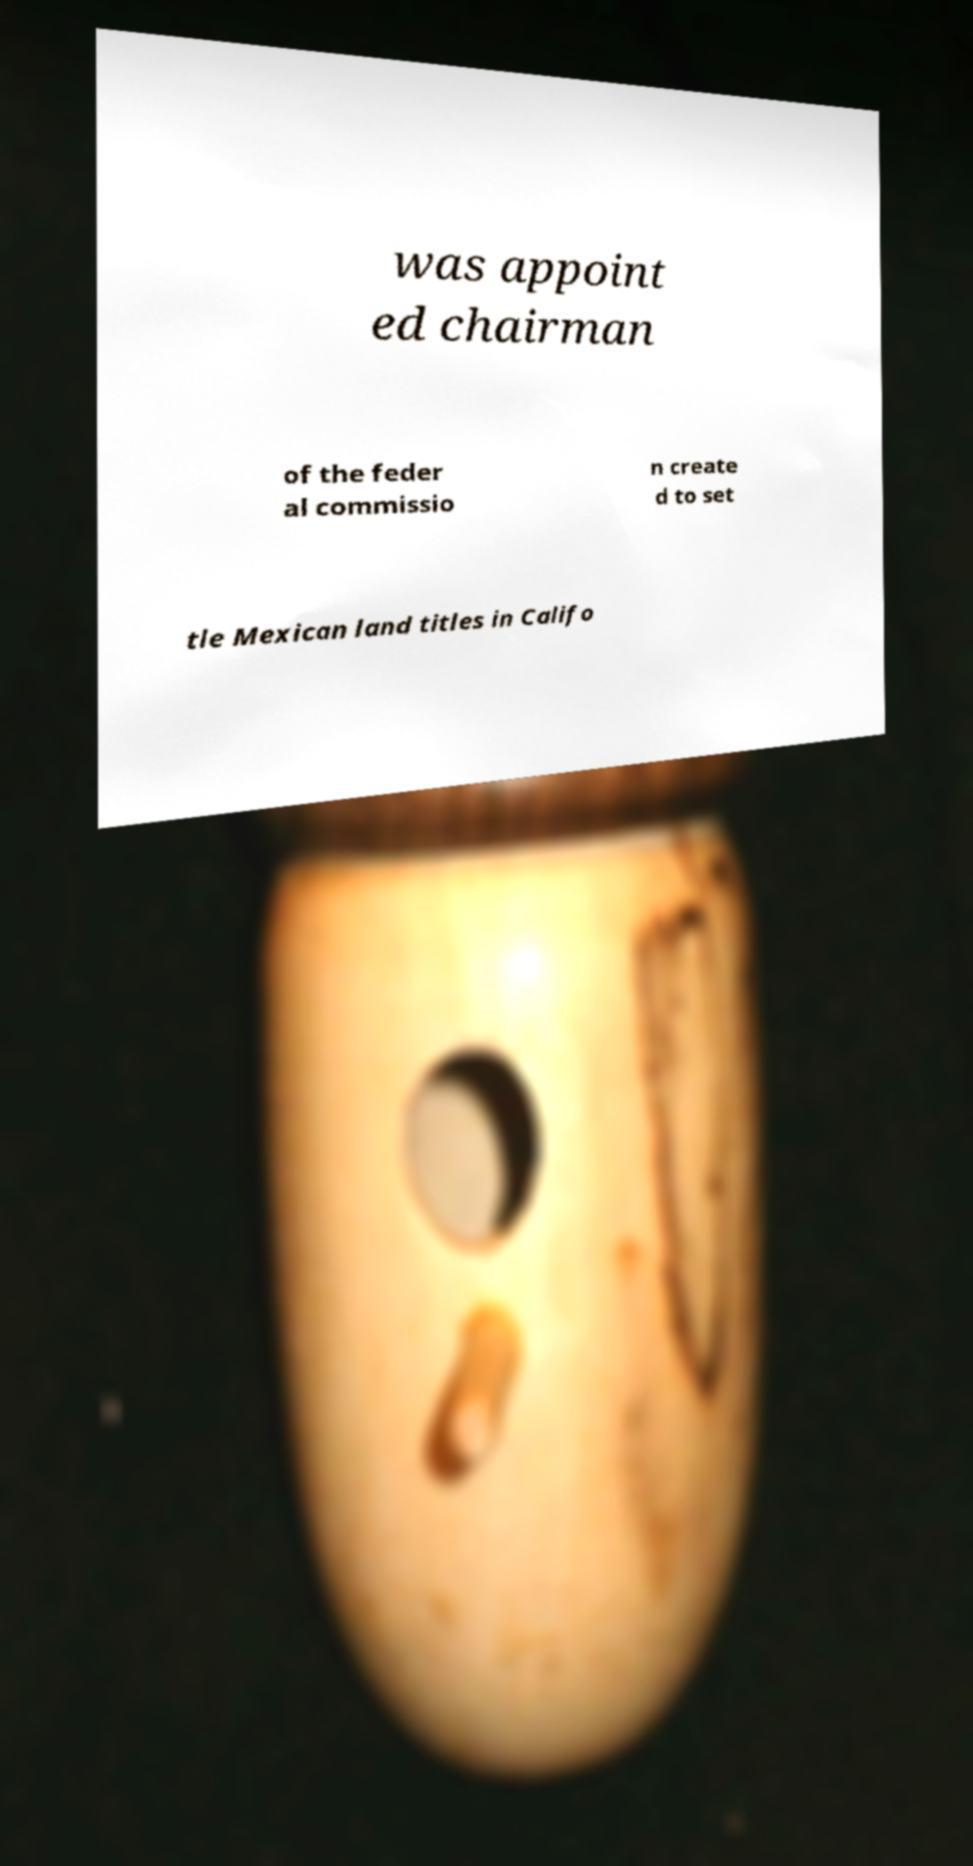Can you read and provide the text displayed in the image?This photo seems to have some interesting text. Can you extract and type it out for me? was appoint ed chairman of the feder al commissio n create d to set tle Mexican land titles in Califo 